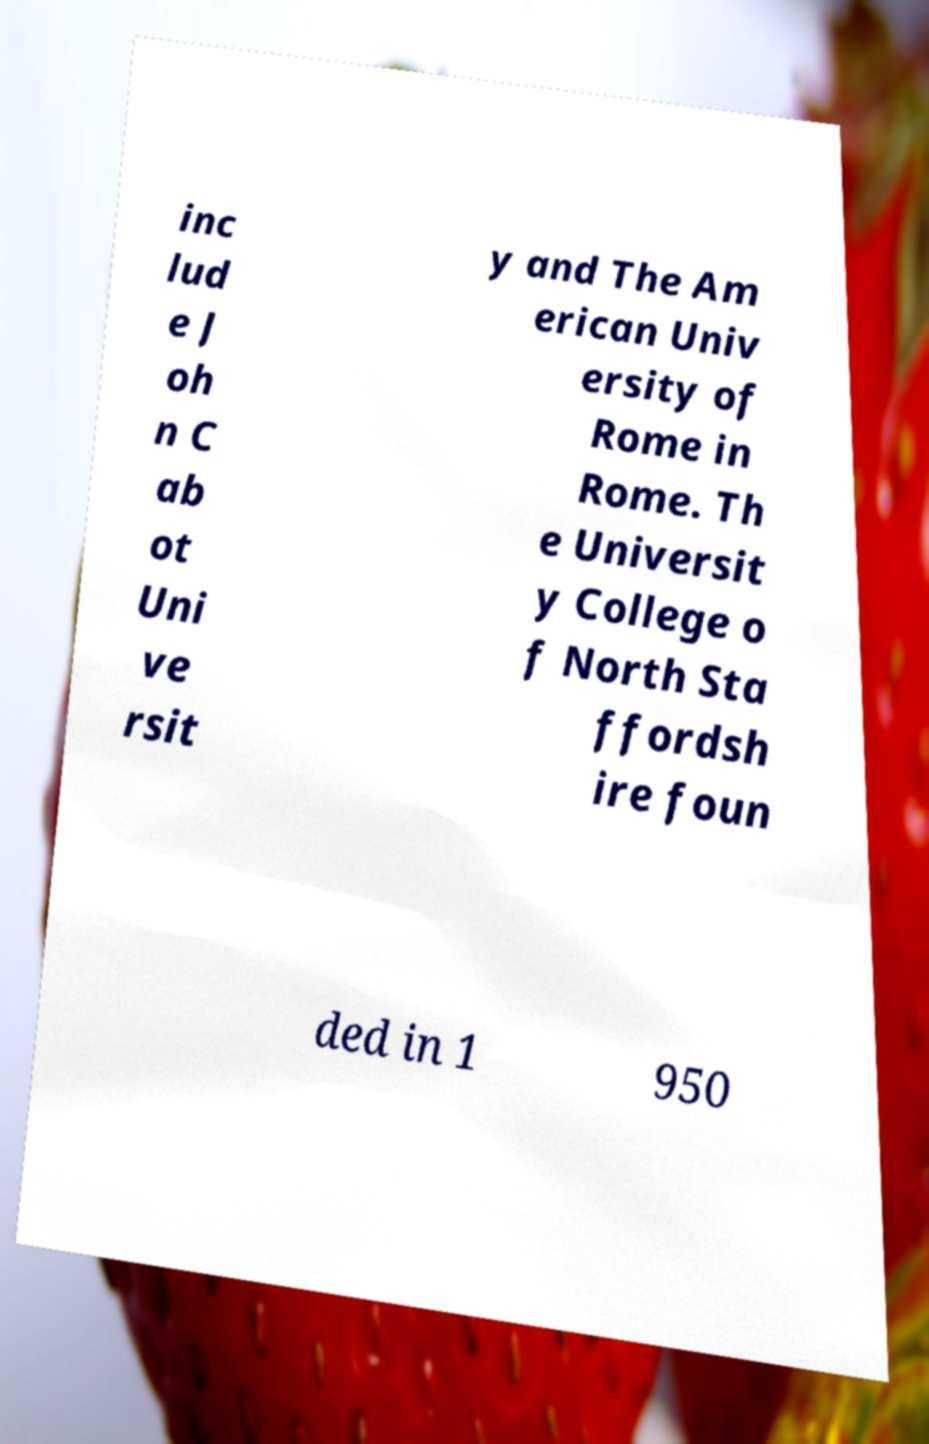Can you read and provide the text displayed in the image?This photo seems to have some interesting text. Can you extract and type it out for me? inc lud e J oh n C ab ot Uni ve rsit y and The Am erican Univ ersity of Rome in Rome. Th e Universit y College o f North Sta ffordsh ire foun ded in 1 950 